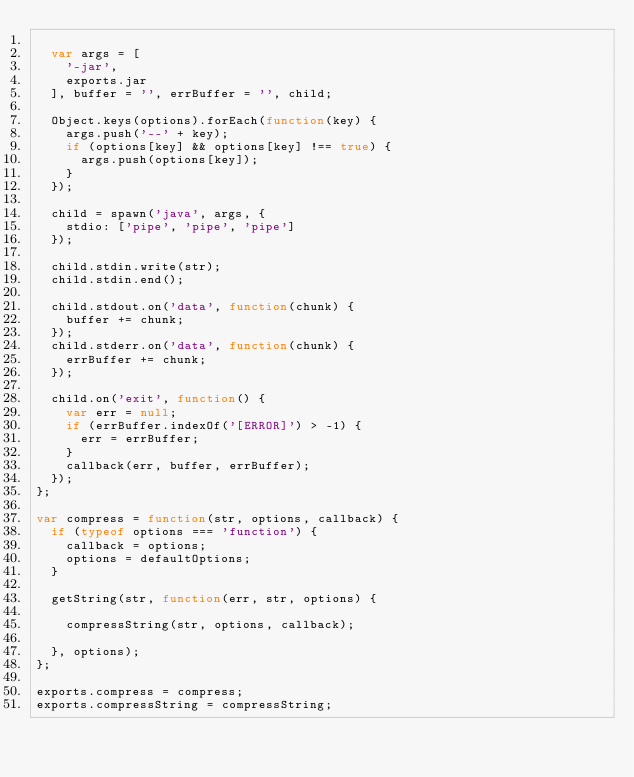Convert code to text. <code><loc_0><loc_0><loc_500><loc_500><_JavaScript_>
	var args = [
		'-jar',
		exports.jar
	], buffer = '', errBuffer = '', child;

	Object.keys(options).forEach(function(key) {
		args.push('--' + key);
		if (options[key] && options[key] !== true) {
			args.push(options[key]);
		}
	});

	child = spawn('java', args, {
		stdio: ['pipe', 'pipe', 'pipe']
	});

	child.stdin.write(str);
	child.stdin.end();

	child.stdout.on('data', function(chunk) {
		buffer += chunk;
	});
	child.stderr.on('data', function(chunk) {
		errBuffer += chunk;
	});

	child.on('exit', function() {
		var err = null;
		if (errBuffer.indexOf('[ERROR]') > -1) {
			err = errBuffer;
		}
		callback(err, buffer, errBuffer);
	});
};

var compress = function(str, options, callback) {
	if (typeof options === 'function') {
		callback = options;
		options = defaultOptions;
	}

	getString(str, function(err, str, options) {

		compressString(str, options, callback);

	}, options);
};

exports.compress = compress;
exports.compressString = compressString;
</code> 